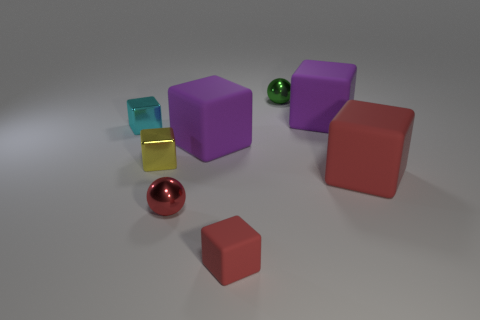What number of metallic spheres are the same size as the cyan metallic cube?
Offer a very short reply. 2. What is the material of the small red cube?
Ensure brevity in your answer.  Rubber. Is the number of tiny green metallic spheres greater than the number of big red matte cylinders?
Offer a terse response. Yes. Does the large red rubber thing have the same shape as the small green metal object?
Your answer should be very brief. No. Do the metallic ball that is to the left of the tiny red rubber block and the sphere that is behind the tiny cyan metal thing have the same color?
Your answer should be very brief. No. Are there fewer cyan shiny cubes that are left of the small yellow metal object than red rubber things to the right of the red metallic thing?
Offer a very short reply. Yes. The tiny shiny thing in front of the small yellow metallic thing has what shape?
Your answer should be very brief. Sphere. There is a large object that is the same color as the tiny matte thing; what material is it?
Ensure brevity in your answer.  Rubber. What number of other things are there of the same material as the tiny yellow object
Offer a terse response. 3. There is a small matte thing; does it have the same shape as the metal thing right of the small red rubber thing?
Keep it short and to the point. No. 